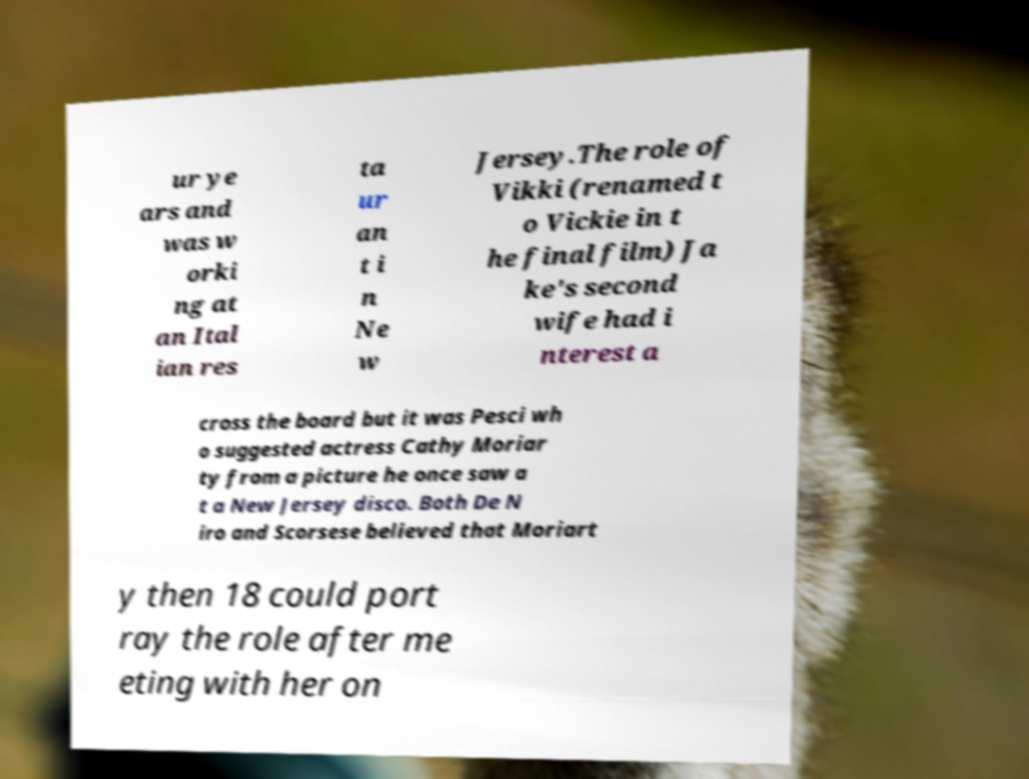What messages or text are displayed in this image? I need them in a readable, typed format. ur ye ars and was w orki ng at an Ital ian res ta ur an t i n Ne w Jersey.The role of Vikki (renamed t o Vickie in t he final film) Ja ke's second wife had i nterest a cross the board but it was Pesci wh o suggested actress Cathy Moriar ty from a picture he once saw a t a New Jersey disco. Both De N iro and Scorsese believed that Moriart y then 18 could port ray the role after me eting with her on 